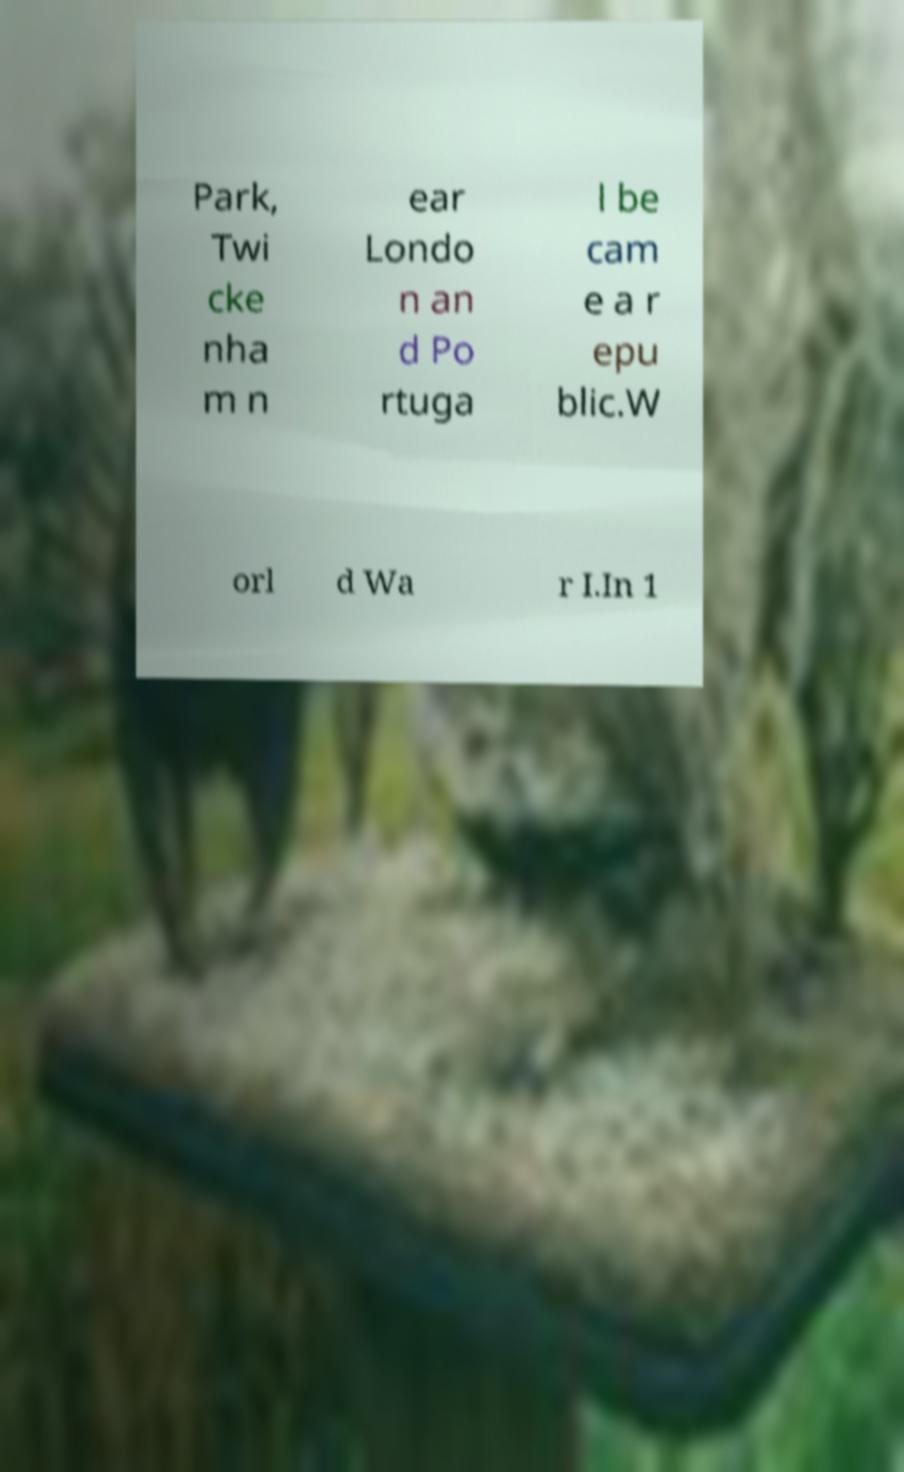What messages or text are displayed in this image? I need them in a readable, typed format. Park, Twi cke nha m n ear Londo n an d Po rtuga l be cam e a r epu blic.W orl d Wa r I.In 1 